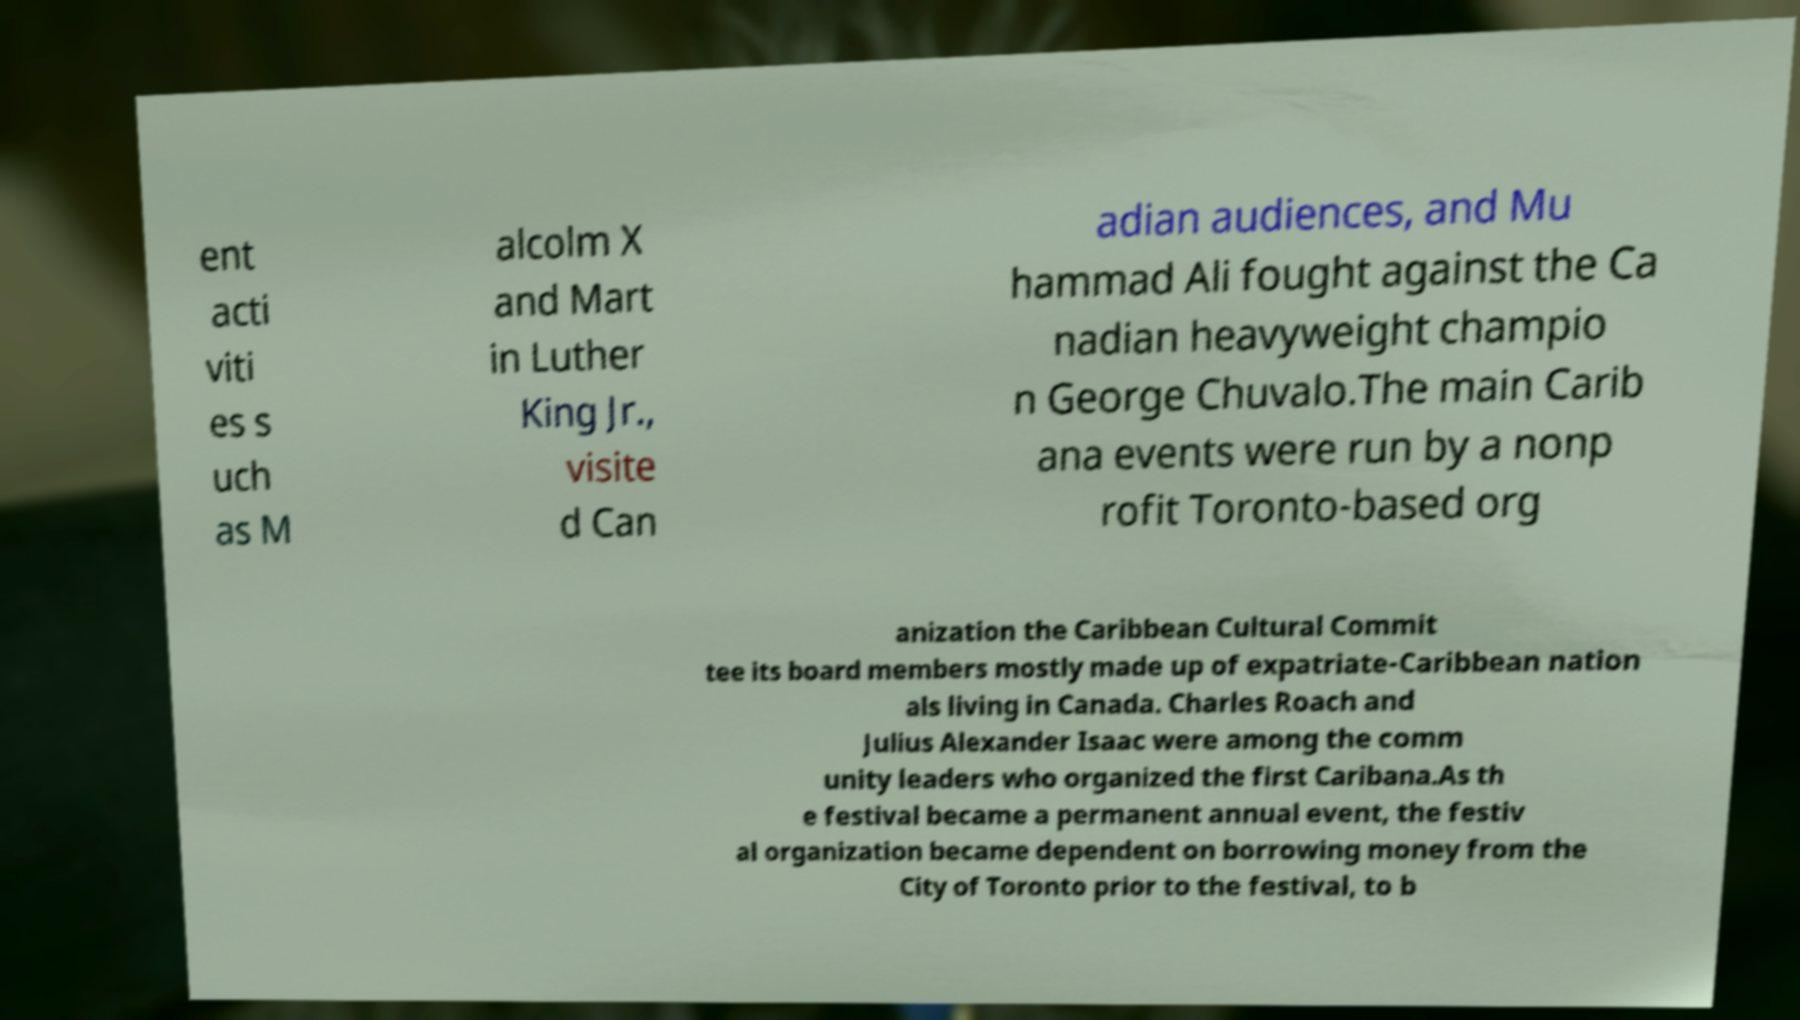Could you assist in decoding the text presented in this image and type it out clearly? ent acti viti es s uch as M alcolm X and Mart in Luther King Jr., visite d Can adian audiences, and Mu hammad Ali fought against the Ca nadian heavyweight champio n George Chuvalo.The main Carib ana events were run by a nonp rofit Toronto-based org anization the Caribbean Cultural Commit tee its board members mostly made up of expatriate-Caribbean nation als living in Canada. Charles Roach and Julius Alexander Isaac were among the comm unity leaders who organized the first Caribana.As th e festival became a permanent annual event, the festiv al organization became dependent on borrowing money from the City of Toronto prior to the festival, to b 